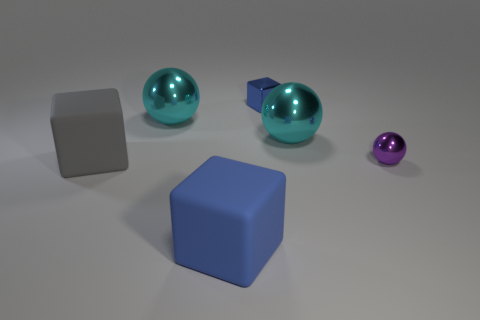What textures do the objects appear to have? The grey cube appears to have a matte, non-reflective surface suggesting a solid, possibly metallic texture. The large cyan spheres have a glossy, reflective exterior indicating they might be made of glass or a polished metal. The small purple sphere shares this shiny quality. The blue cube, with its slightly light-diffusing surface, appears to be made of rubber. 